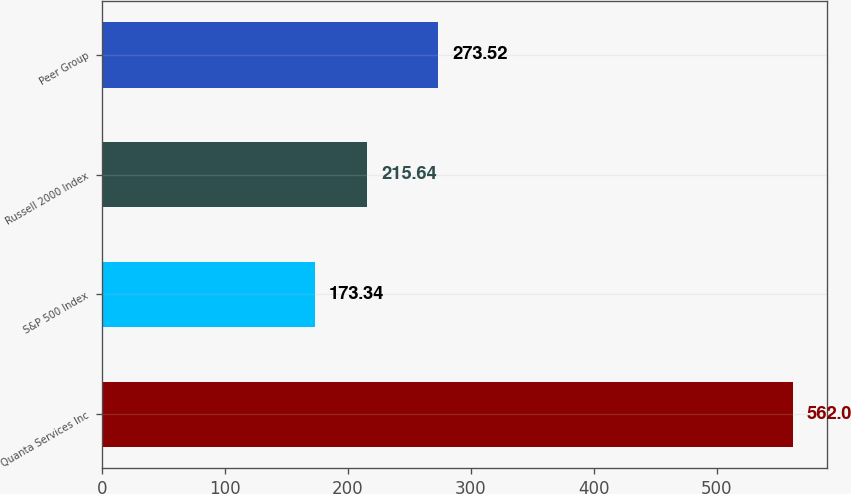Convert chart. <chart><loc_0><loc_0><loc_500><loc_500><bar_chart><fcel>Quanta Services Inc<fcel>S&P 500 Index<fcel>Russell 2000 Index<fcel>Peer Group<nl><fcel>562<fcel>173.34<fcel>215.64<fcel>273.52<nl></chart> 